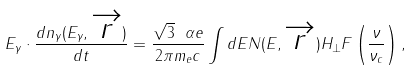<formula> <loc_0><loc_0><loc_500><loc_500>E _ { \gamma } \cdot \frac { d n _ { \gamma } ( E _ { \gamma } , \overrightarrow { r } ) } { d t } = \frac { \sqrt { 3 } \ \alpha e } { 2 \pi m _ { e } c } \int d E N ( E , \overrightarrow { r } ) H _ { \bot } F \left ( \frac { \nu } { \nu _ { c } } \right ) ,</formula> 